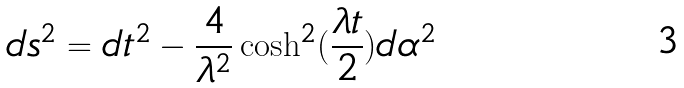<formula> <loc_0><loc_0><loc_500><loc_500>d s ^ { 2 } = d t ^ { 2 } - \frac { 4 } { \lambda ^ { 2 } } \cosh ^ { 2 } ( \frac { \lambda t } { 2 } ) d \alpha ^ { 2 }</formula> 